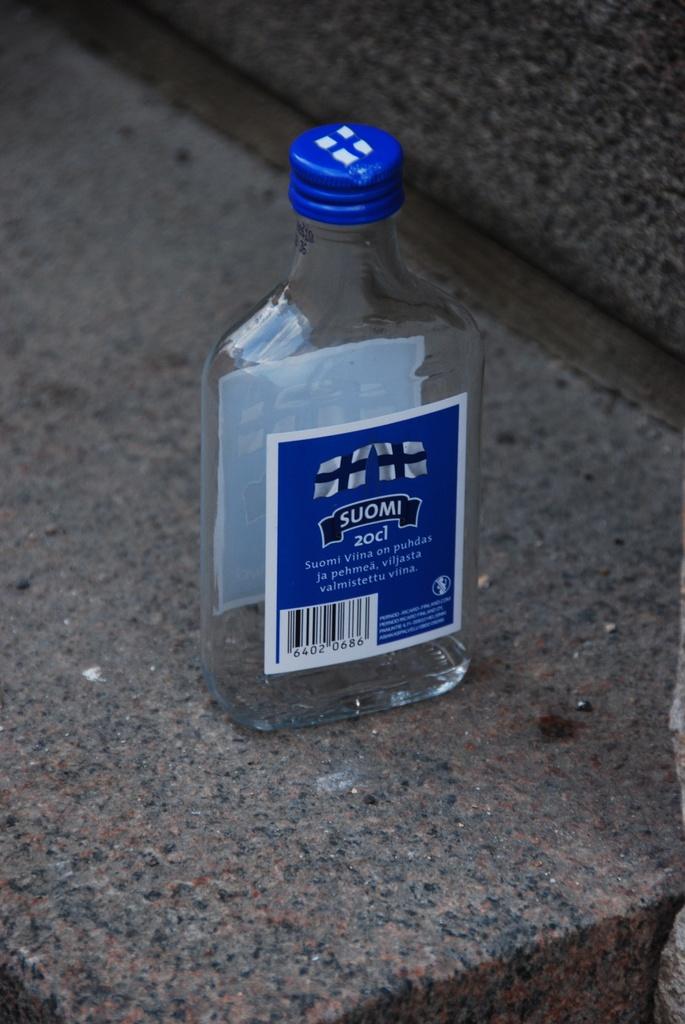What is the name of this drink?
Give a very brief answer. Suomi. How much is in there?
Offer a terse response. 20cl. 